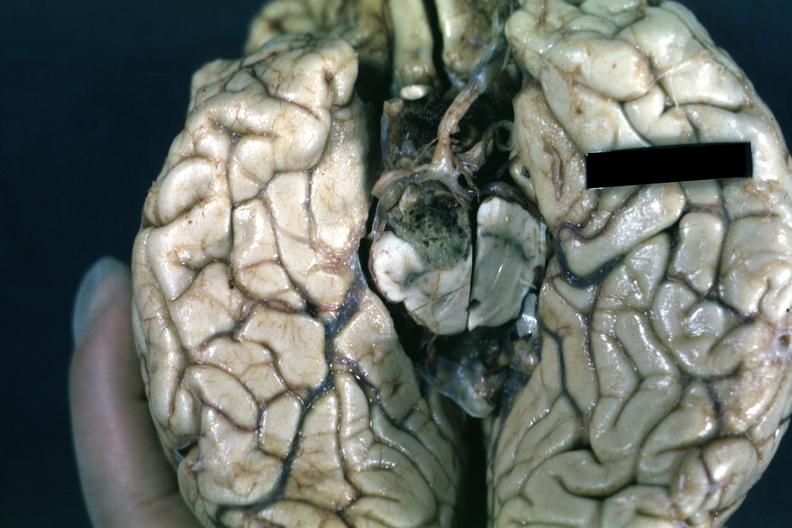s opened muscle present?
Answer the question using a single word or phrase. No 